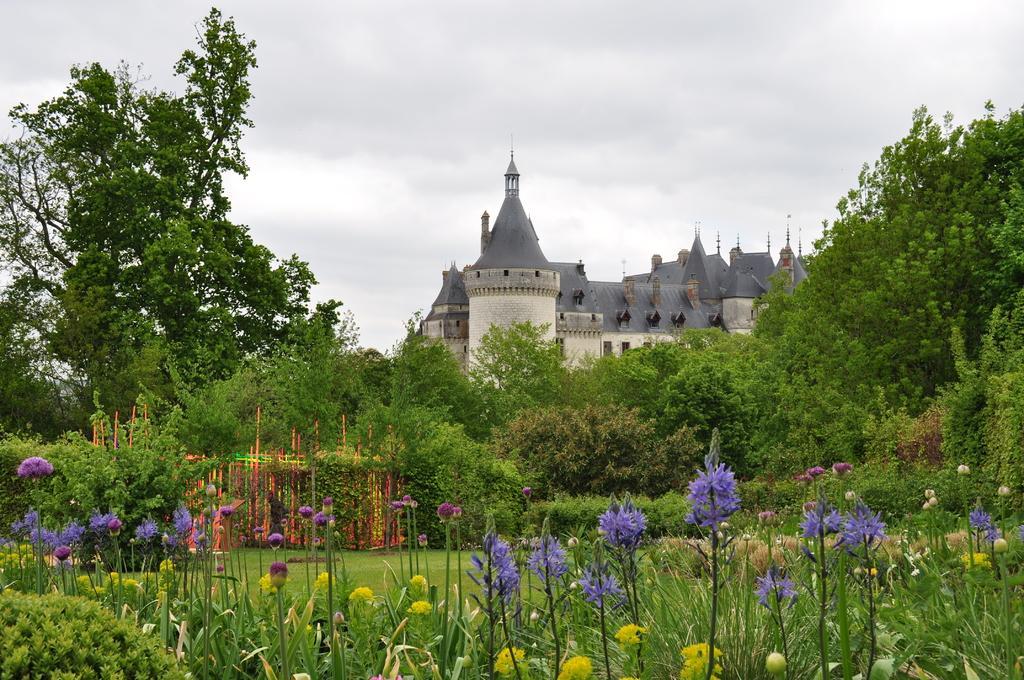How would you summarize this image in a sentence or two? In this image I can see number of flowers, grass, number of trees and in background I can see a building and cloudy sky. 